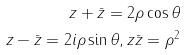<formula> <loc_0><loc_0><loc_500><loc_500>z + \bar { z } = 2 \rho \cos \theta \\ z - \bar { z } = 2 i \rho \sin \theta , z \bar { z } = \rho ^ { 2 }</formula> 